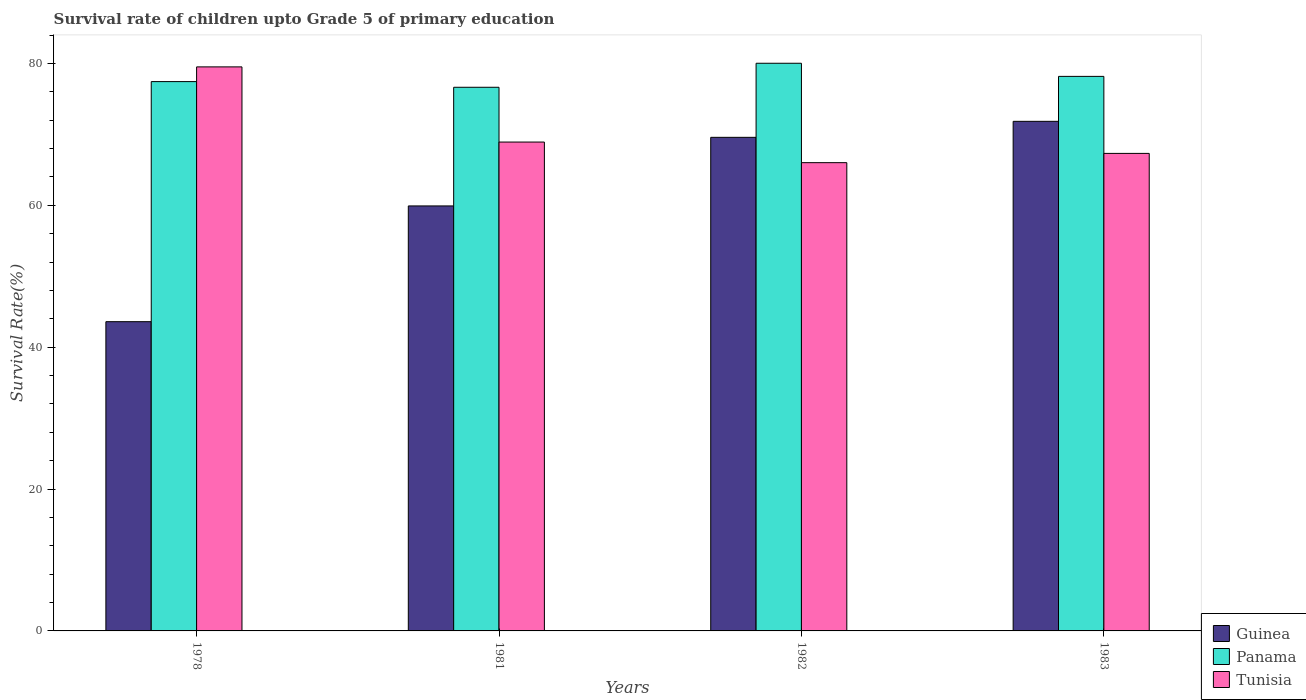How many groups of bars are there?
Provide a succinct answer. 4. Are the number of bars per tick equal to the number of legend labels?
Make the answer very short. Yes. Are the number of bars on each tick of the X-axis equal?
Ensure brevity in your answer.  Yes. How many bars are there on the 4th tick from the left?
Make the answer very short. 3. How many bars are there on the 3rd tick from the right?
Keep it short and to the point. 3. What is the label of the 1st group of bars from the left?
Your answer should be compact. 1978. In how many cases, is the number of bars for a given year not equal to the number of legend labels?
Provide a short and direct response. 0. What is the survival rate of children in Guinea in 1978?
Keep it short and to the point. 43.6. Across all years, what is the maximum survival rate of children in Tunisia?
Ensure brevity in your answer.  79.52. Across all years, what is the minimum survival rate of children in Guinea?
Make the answer very short. 43.6. In which year was the survival rate of children in Panama maximum?
Provide a succinct answer. 1982. In which year was the survival rate of children in Guinea minimum?
Keep it short and to the point. 1978. What is the total survival rate of children in Tunisia in the graph?
Provide a succinct answer. 281.77. What is the difference between the survival rate of children in Guinea in 1978 and that in 1981?
Keep it short and to the point. -16.32. What is the difference between the survival rate of children in Guinea in 1982 and the survival rate of children in Tunisia in 1978?
Your response must be concise. -9.93. What is the average survival rate of children in Guinea per year?
Give a very brief answer. 61.23. In the year 1981, what is the difference between the survival rate of children in Tunisia and survival rate of children in Guinea?
Offer a terse response. 9. In how many years, is the survival rate of children in Tunisia greater than 8 %?
Offer a very short reply. 4. What is the ratio of the survival rate of children in Tunisia in 1978 to that in 1981?
Offer a very short reply. 1.15. Is the survival rate of children in Panama in 1978 less than that in 1982?
Ensure brevity in your answer.  Yes. What is the difference between the highest and the second highest survival rate of children in Tunisia?
Your response must be concise. 10.6. What is the difference between the highest and the lowest survival rate of children in Tunisia?
Give a very brief answer. 13.5. In how many years, is the survival rate of children in Guinea greater than the average survival rate of children in Guinea taken over all years?
Your response must be concise. 2. Is the sum of the survival rate of children in Panama in 1982 and 1983 greater than the maximum survival rate of children in Tunisia across all years?
Ensure brevity in your answer.  Yes. What does the 3rd bar from the left in 1983 represents?
Your answer should be compact. Tunisia. What does the 2nd bar from the right in 1978 represents?
Keep it short and to the point. Panama. How many bars are there?
Ensure brevity in your answer.  12. How many years are there in the graph?
Keep it short and to the point. 4. What is the difference between two consecutive major ticks on the Y-axis?
Offer a terse response. 20. Are the values on the major ticks of Y-axis written in scientific E-notation?
Your answer should be compact. No. Where does the legend appear in the graph?
Give a very brief answer. Bottom right. What is the title of the graph?
Keep it short and to the point. Survival rate of children upto Grade 5 of primary education. Does "Sao Tome and Principe" appear as one of the legend labels in the graph?
Make the answer very short. No. What is the label or title of the X-axis?
Offer a very short reply. Years. What is the label or title of the Y-axis?
Your response must be concise. Survival Rate(%). What is the Survival Rate(%) in Guinea in 1978?
Keep it short and to the point. 43.6. What is the Survival Rate(%) of Panama in 1978?
Your response must be concise. 77.44. What is the Survival Rate(%) in Tunisia in 1978?
Offer a terse response. 79.52. What is the Survival Rate(%) in Guinea in 1981?
Your answer should be very brief. 59.92. What is the Survival Rate(%) in Panama in 1981?
Offer a very short reply. 76.64. What is the Survival Rate(%) in Tunisia in 1981?
Offer a very short reply. 68.92. What is the Survival Rate(%) of Guinea in 1982?
Make the answer very short. 69.59. What is the Survival Rate(%) in Panama in 1982?
Provide a short and direct response. 80.03. What is the Survival Rate(%) in Tunisia in 1982?
Ensure brevity in your answer.  66.01. What is the Survival Rate(%) of Guinea in 1983?
Provide a succinct answer. 71.84. What is the Survival Rate(%) of Panama in 1983?
Provide a succinct answer. 78.18. What is the Survival Rate(%) in Tunisia in 1983?
Your response must be concise. 67.32. Across all years, what is the maximum Survival Rate(%) of Guinea?
Give a very brief answer. 71.84. Across all years, what is the maximum Survival Rate(%) in Panama?
Your answer should be very brief. 80.03. Across all years, what is the maximum Survival Rate(%) of Tunisia?
Make the answer very short. 79.52. Across all years, what is the minimum Survival Rate(%) in Guinea?
Offer a terse response. 43.6. Across all years, what is the minimum Survival Rate(%) of Panama?
Give a very brief answer. 76.64. Across all years, what is the minimum Survival Rate(%) of Tunisia?
Keep it short and to the point. 66.01. What is the total Survival Rate(%) in Guinea in the graph?
Offer a very short reply. 244.94. What is the total Survival Rate(%) of Panama in the graph?
Provide a succinct answer. 312.29. What is the total Survival Rate(%) in Tunisia in the graph?
Your answer should be compact. 281.77. What is the difference between the Survival Rate(%) of Guinea in 1978 and that in 1981?
Offer a very short reply. -16.32. What is the difference between the Survival Rate(%) in Panama in 1978 and that in 1981?
Provide a succinct answer. 0.8. What is the difference between the Survival Rate(%) of Tunisia in 1978 and that in 1981?
Give a very brief answer. 10.6. What is the difference between the Survival Rate(%) in Guinea in 1978 and that in 1982?
Provide a short and direct response. -25.99. What is the difference between the Survival Rate(%) in Panama in 1978 and that in 1982?
Provide a succinct answer. -2.59. What is the difference between the Survival Rate(%) in Tunisia in 1978 and that in 1982?
Provide a short and direct response. 13.5. What is the difference between the Survival Rate(%) of Guinea in 1978 and that in 1983?
Your answer should be compact. -28.24. What is the difference between the Survival Rate(%) of Panama in 1978 and that in 1983?
Your response must be concise. -0.74. What is the difference between the Survival Rate(%) of Tunisia in 1978 and that in 1983?
Your response must be concise. 12.2. What is the difference between the Survival Rate(%) of Guinea in 1981 and that in 1982?
Ensure brevity in your answer.  -9.67. What is the difference between the Survival Rate(%) of Panama in 1981 and that in 1982?
Give a very brief answer. -3.39. What is the difference between the Survival Rate(%) in Tunisia in 1981 and that in 1982?
Give a very brief answer. 2.9. What is the difference between the Survival Rate(%) of Guinea in 1981 and that in 1983?
Keep it short and to the point. -11.92. What is the difference between the Survival Rate(%) in Panama in 1981 and that in 1983?
Provide a succinct answer. -1.54. What is the difference between the Survival Rate(%) in Tunisia in 1981 and that in 1983?
Make the answer very short. 1.6. What is the difference between the Survival Rate(%) of Guinea in 1982 and that in 1983?
Your answer should be very brief. -2.26. What is the difference between the Survival Rate(%) of Panama in 1982 and that in 1983?
Your answer should be very brief. 1.85. What is the difference between the Survival Rate(%) in Tunisia in 1982 and that in 1983?
Offer a terse response. -1.31. What is the difference between the Survival Rate(%) in Guinea in 1978 and the Survival Rate(%) in Panama in 1981?
Ensure brevity in your answer.  -33.04. What is the difference between the Survival Rate(%) in Guinea in 1978 and the Survival Rate(%) in Tunisia in 1981?
Make the answer very short. -25.32. What is the difference between the Survival Rate(%) in Panama in 1978 and the Survival Rate(%) in Tunisia in 1981?
Ensure brevity in your answer.  8.52. What is the difference between the Survival Rate(%) of Guinea in 1978 and the Survival Rate(%) of Panama in 1982?
Offer a very short reply. -36.43. What is the difference between the Survival Rate(%) in Guinea in 1978 and the Survival Rate(%) in Tunisia in 1982?
Your response must be concise. -22.42. What is the difference between the Survival Rate(%) of Panama in 1978 and the Survival Rate(%) of Tunisia in 1982?
Your answer should be very brief. 11.43. What is the difference between the Survival Rate(%) in Guinea in 1978 and the Survival Rate(%) in Panama in 1983?
Provide a succinct answer. -34.58. What is the difference between the Survival Rate(%) in Guinea in 1978 and the Survival Rate(%) in Tunisia in 1983?
Offer a terse response. -23.72. What is the difference between the Survival Rate(%) in Panama in 1978 and the Survival Rate(%) in Tunisia in 1983?
Offer a terse response. 10.12. What is the difference between the Survival Rate(%) of Guinea in 1981 and the Survival Rate(%) of Panama in 1982?
Your response must be concise. -20.11. What is the difference between the Survival Rate(%) in Guinea in 1981 and the Survival Rate(%) in Tunisia in 1982?
Provide a succinct answer. -6.1. What is the difference between the Survival Rate(%) in Panama in 1981 and the Survival Rate(%) in Tunisia in 1982?
Provide a short and direct response. 10.63. What is the difference between the Survival Rate(%) in Guinea in 1981 and the Survival Rate(%) in Panama in 1983?
Keep it short and to the point. -18.26. What is the difference between the Survival Rate(%) in Guinea in 1981 and the Survival Rate(%) in Tunisia in 1983?
Give a very brief answer. -7.4. What is the difference between the Survival Rate(%) in Panama in 1981 and the Survival Rate(%) in Tunisia in 1983?
Your answer should be compact. 9.32. What is the difference between the Survival Rate(%) in Guinea in 1982 and the Survival Rate(%) in Panama in 1983?
Offer a very short reply. -8.59. What is the difference between the Survival Rate(%) in Guinea in 1982 and the Survival Rate(%) in Tunisia in 1983?
Provide a short and direct response. 2.27. What is the difference between the Survival Rate(%) of Panama in 1982 and the Survival Rate(%) of Tunisia in 1983?
Offer a terse response. 12.71. What is the average Survival Rate(%) of Guinea per year?
Your answer should be very brief. 61.23. What is the average Survival Rate(%) in Panama per year?
Your answer should be compact. 78.07. What is the average Survival Rate(%) in Tunisia per year?
Offer a terse response. 70.44. In the year 1978, what is the difference between the Survival Rate(%) in Guinea and Survival Rate(%) in Panama?
Your answer should be very brief. -33.85. In the year 1978, what is the difference between the Survival Rate(%) of Guinea and Survival Rate(%) of Tunisia?
Your response must be concise. -35.92. In the year 1978, what is the difference between the Survival Rate(%) of Panama and Survival Rate(%) of Tunisia?
Offer a very short reply. -2.07. In the year 1981, what is the difference between the Survival Rate(%) of Guinea and Survival Rate(%) of Panama?
Your answer should be very brief. -16.73. In the year 1981, what is the difference between the Survival Rate(%) in Guinea and Survival Rate(%) in Tunisia?
Your response must be concise. -9. In the year 1981, what is the difference between the Survival Rate(%) in Panama and Survival Rate(%) in Tunisia?
Make the answer very short. 7.72. In the year 1982, what is the difference between the Survival Rate(%) of Guinea and Survival Rate(%) of Panama?
Your answer should be compact. -10.44. In the year 1982, what is the difference between the Survival Rate(%) in Guinea and Survival Rate(%) in Tunisia?
Make the answer very short. 3.57. In the year 1982, what is the difference between the Survival Rate(%) of Panama and Survival Rate(%) of Tunisia?
Ensure brevity in your answer.  14.01. In the year 1983, what is the difference between the Survival Rate(%) of Guinea and Survival Rate(%) of Panama?
Make the answer very short. -6.34. In the year 1983, what is the difference between the Survival Rate(%) in Guinea and Survival Rate(%) in Tunisia?
Your answer should be very brief. 4.52. In the year 1983, what is the difference between the Survival Rate(%) of Panama and Survival Rate(%) of Tunisia?
Offer a terse response. 10.86. What is the ratio of the Survival Rate(%) in Guinea in 1978 to that in 1981?
Keep it short and to the point. 0.73. What is the ratio of the Survival Rate(%) of Panama in 1978 to that in 1981?
Keep it short and to the point. 1.01. What is the ratio of the Survival Rate(%) of Tunisia in 1978 to that in 1981?
Offer a very short reply. 1.15. What is the ratio of the Survival Rate(%) in Guinea in 1978 to that in 1982?
Provide a succinct answer. 0.63. What is the ratio of the Survival Rate(%) of Panama in 1978 to that in 1982?
Give a very brief answer. 0.97. What is the ratio of the Survival Rate(%) in Tunisia in 1978 to that in 1982?
Offer a very short reply. 1.2. What is the ratio of the Survival Rate(%) of Guinea in 1978 to that in 1983?
Provide a short and direct response. 0.61. What is the ratio of the Survival Rate(%) in Panama in 1978 to that in 1983?
Make the answer very short. 0.99. What is the ratio of the Survival Rate(%) in Tunisia in 1978 to that in 1983?
Offer a very short reply. 1.18. What is the ratio of the Survival Rate(%) in Guinea in 1981 to that in 1982?
Provide a short and direct response. 0.86. What is the ratio of the Survival Rate(%) in Panama in 1981 to that in 1982?
Provide a short and direct response. 0.96. What is the ratio of the Survival Rate(%) of Tunisia in 1981 to that in 1982?
Your answer should be very brief. 1.04. What is the ratio of the Survival Rate(%) of Guinea in 1981 to that in 1983?
Give a very brief answer. 0.83. What is the ratio of the Survival Rate(%) in Panama in 1981 to that in 1983?
Offer a very short reply. 0.98. What is the ratio of the Survival Rate(%) of Tunisia in 1981 to that in 1983?
Your response must be concise. 1.02. What is the ratio of the Survival Rate(%) in Guinea in 1982 to that in 1983?
Ensure brevity in your answer.  0.97. What is the ratio of the Survival Rate(%) of Panama in 1982 to that in 1983?
Make the answer very short. 1.02. What is the ratio of the Survival Rate(%) in Tunisia in 1982 to that in 1983?
Provide a succinct answer. 0.98. What is the difference between the highest and the second highest Survival Rate(%) of Guinea?
Offer a terse response. 2.26. What is the difference between the highest and the second highest Survival Rate(%) in Panama?
Ensure brevity in your answer.  1.85. What is the difference between the highest and the second highest Survival Rate(%) of Tunisia?
Keep it short and to the point. 10.6. What is the difference between the highest and the lowest Survival Rate(%) of Guinea?
Your answer should be very brief. 28.24. What is the difference between the highest and the lowest Survival Rate(%) in Panama?
Offer a terse response. 3.39. What is the difference between the highest and the lowest Survival Rate(%) of Tunisia?
Ensure brevity in your answer.  13.5. 